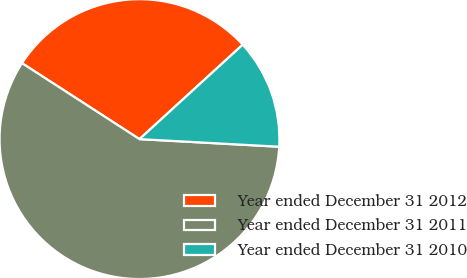Convert chart to OTSL. <chart><loc_0><loc_0><loc_500><loc_500><pie_chart><fcel>Year ended December 31 2012<fcel>Year ended December 31 2011<fcel>Year ended December 31 2010<nl><fcel>29.07%<fcel>58.27%<fcel>12.66%<nl></chart> 